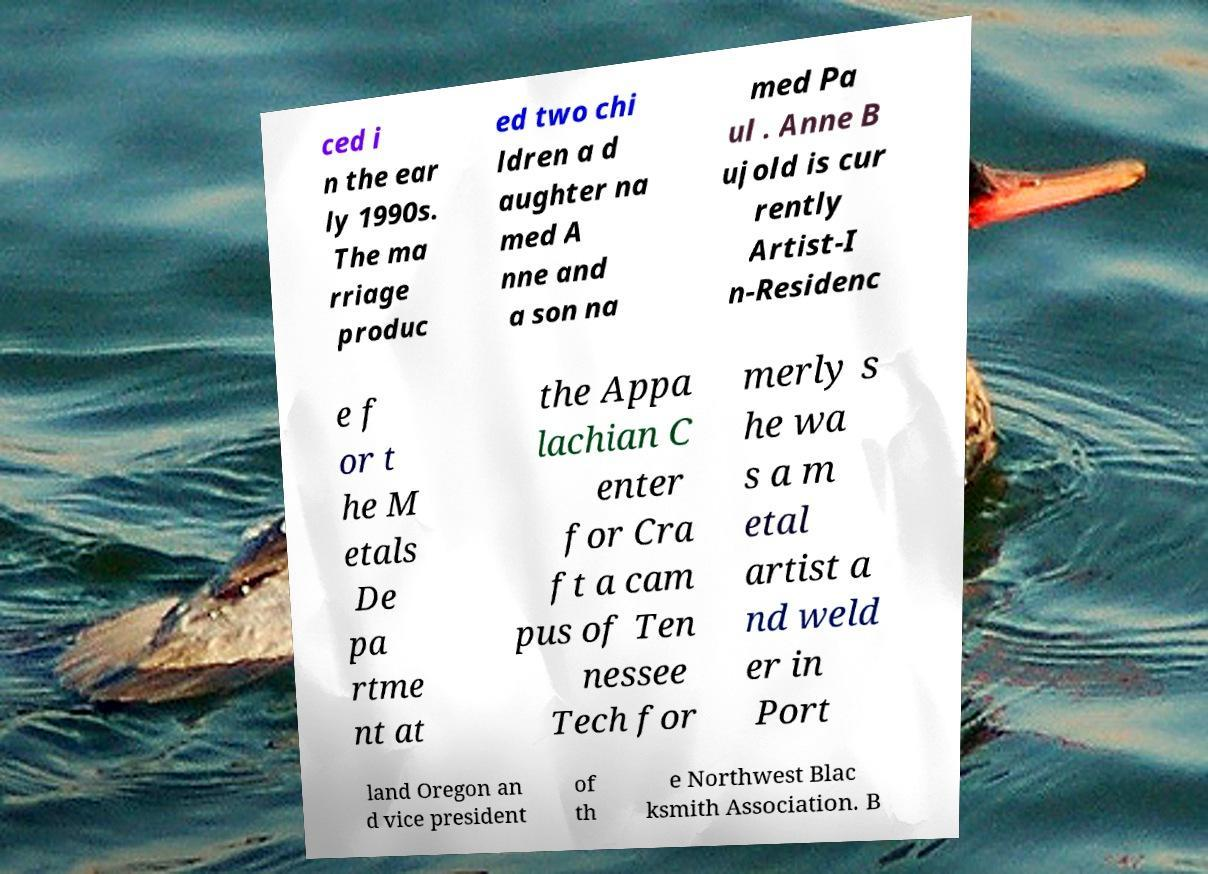For documentation purposes, I need the text within this image transcribed. Could you provide that? ced i n the ear ly 1990s. The ma rriage produc ed two chi ldren a d aughter na med A nne and a son na med Pa ul . Anne B ujold is cur rently Artist-I n-Residenc e f or t he M etals De pa rtme nt at the Appa lachian C enter for Cra ft a cam pus of Ten nessee Tech for merly s he wa s a m etal artist a nd weld er in Port land Oregon an d vice president of th e Northwest Blac ksmith Association. B 